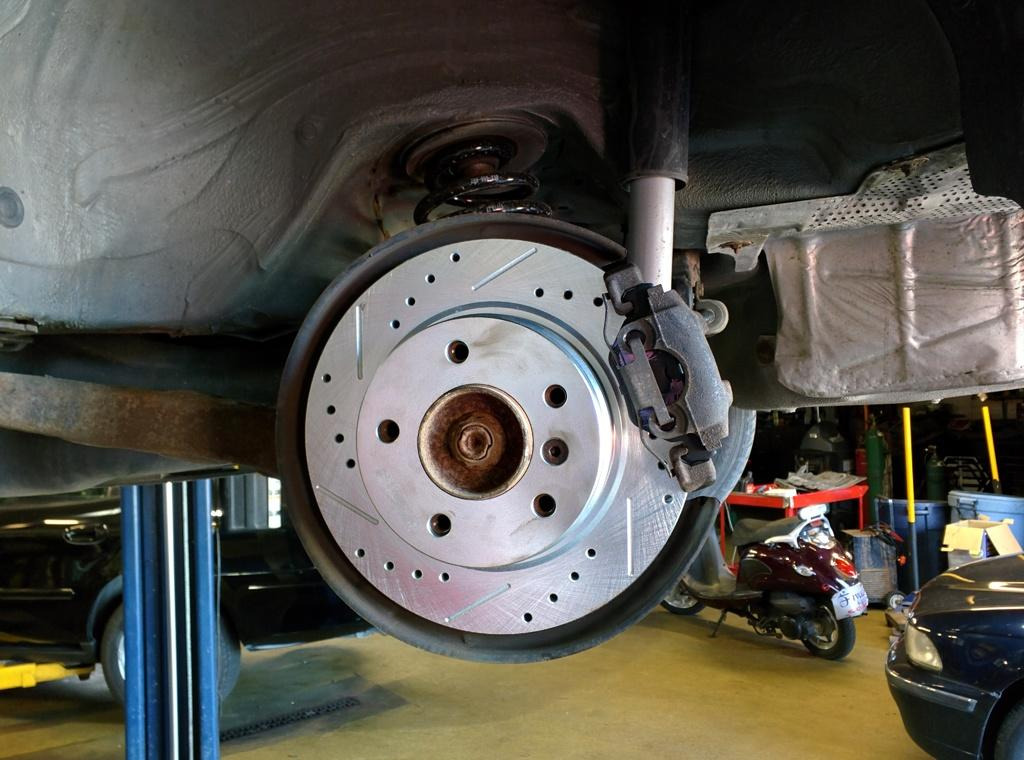What is the main object in the image? There is a brake in the image. What type of vehicle is near the brake? There is a car on the right side of the image. What other mode of transportation is near the car? There is a bike on the right side of the image. What type of square fowl can be seen in the image? There is no square fowl present in the image. Is there a sink visible in the image? There is no sink present in the image. 